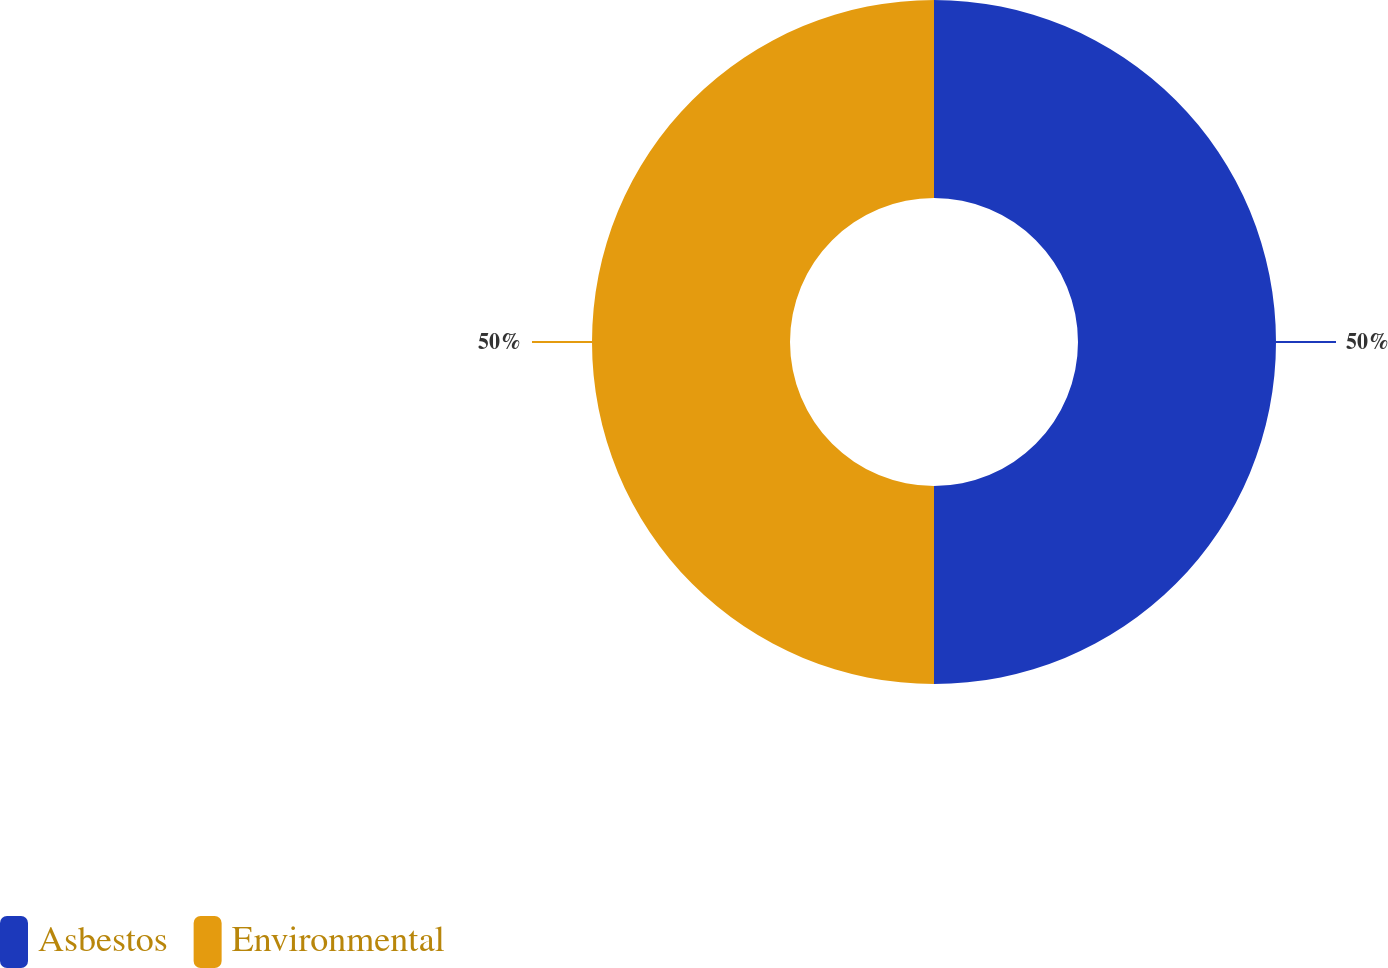Convert chart to OTSL. <chart><loc_0><loc_0><loc_500><loc_500><pie_chart><fcel>Asbestos<fcel>Environmental<nl><fcel>50.0%<fcel>50.0%<nl></chart> 